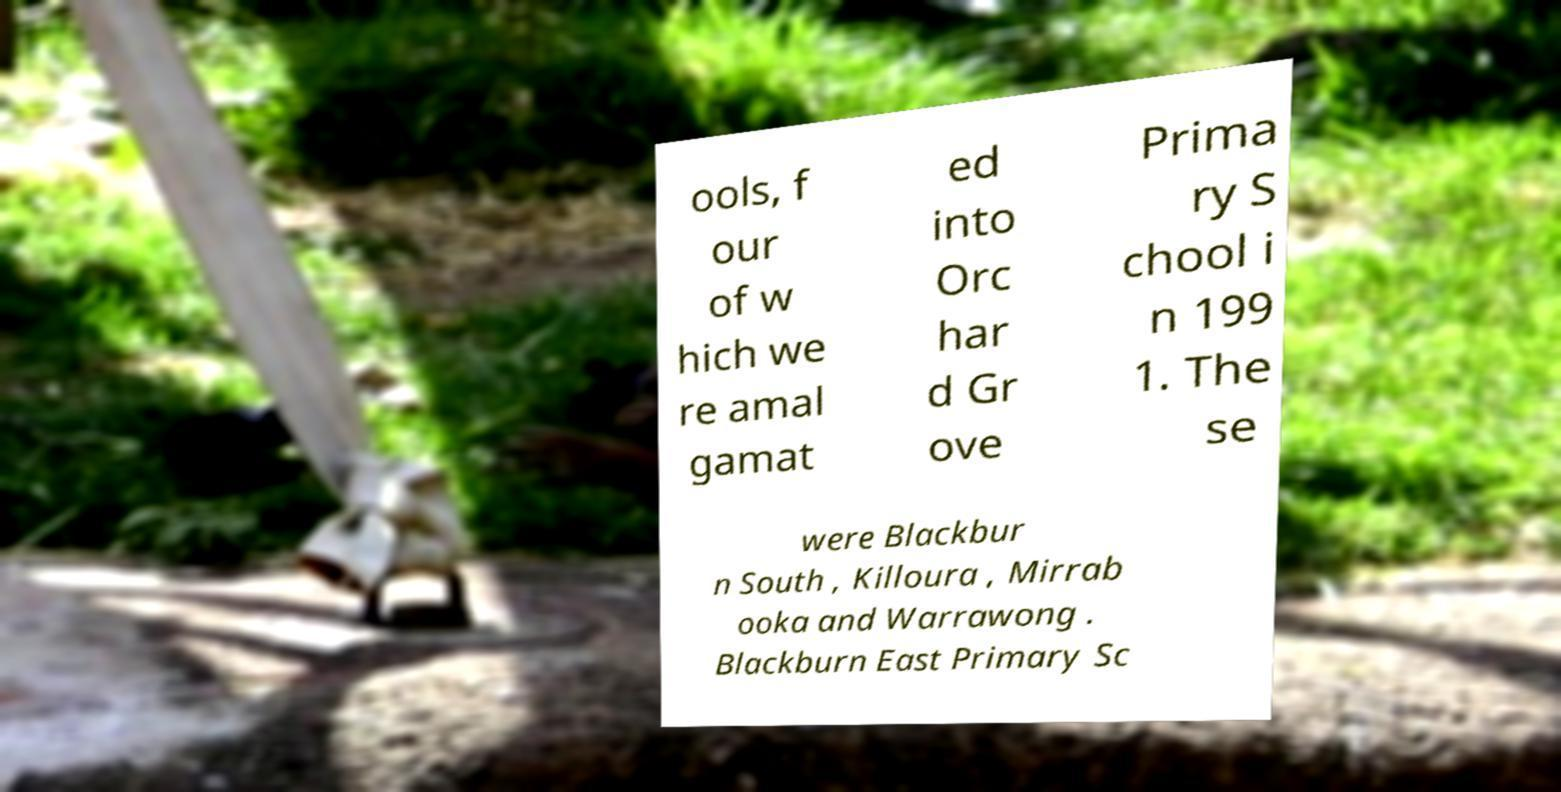Can you read and provide the text displayed in the image?This photo seems to have some interesting text. Can you extract and type it out for me? ools, f our of w hich we re amal gamat ed into Orc har d Gr ove Prima ry S chool i n 199 1. The se were Blackbur n South , Killoura , Mirrab ooka and Warrawong . Blackburn East Primary Sc 